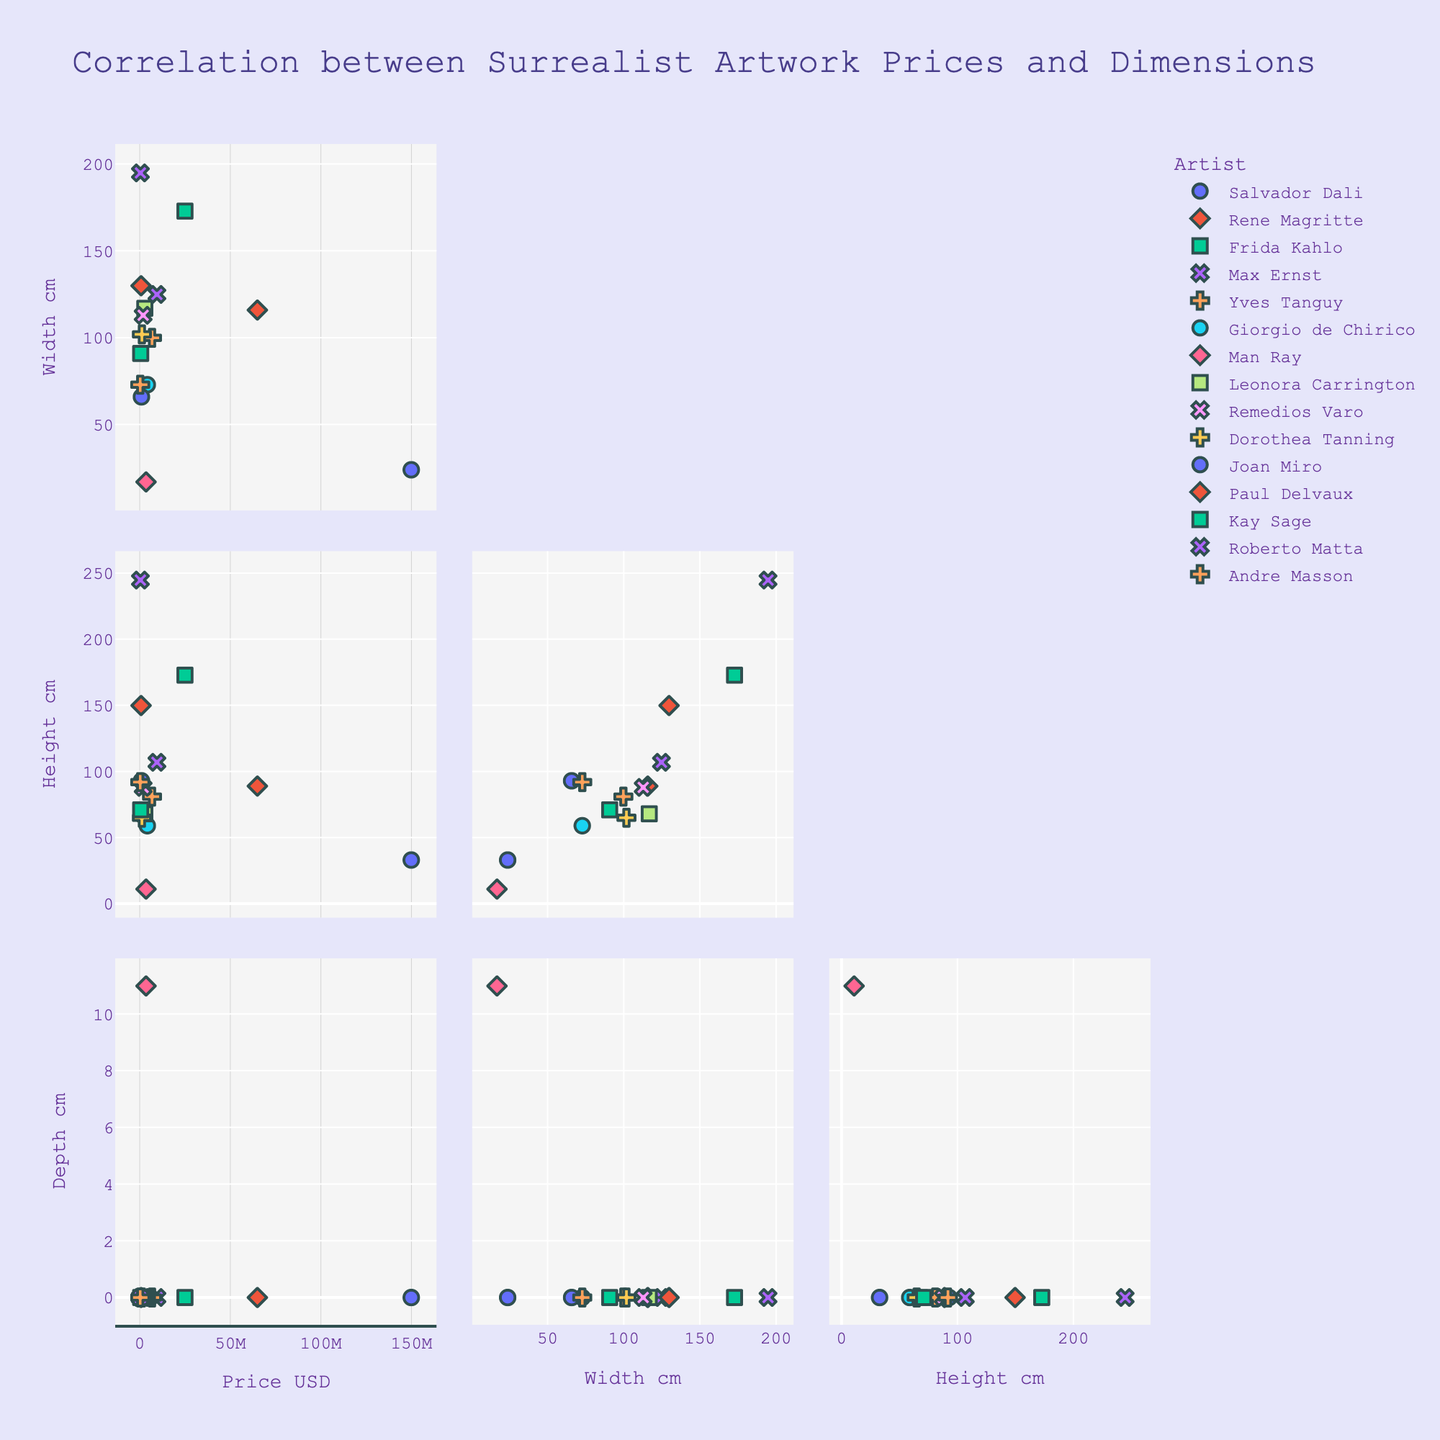What is the title of the plot? The title of the plot is displayed at the top and clearly states the purpose of the plot, which is showing the correlation between artwork prices and dimensions.
Answer: Correlation between Surrealist Artwork Prices and Dimensions How many surrealist artworks have a recorded depth dimension? Look at the 'Depth_cm' dimension axis; count the number of points that are not at zero.
Answer: 1 Which artist's artwork has the highest price? Look at the Price_USD axis and identify the highest data point; trace this point to the corresponding Artist's label.
Answer: Salvador Dali Is there a positive correlation between Price (USD) and Height (cm)? Observe the scatter plot for Price (USD) versus Height (cm) and check if higher prices generally match with higher heights.
Answer: No Which artwork has the greatest height? Find the maximum value on the Height_cm axis and trace it to the corresponding artwork label.
Answer: The Vertigo of Eros Do all artworks with zero depth have different prices? Observe the scatter plots where Depth_cm is zero and compare the prices.
Answer: Yes What dimensions appear to have the most linear relationship with the price? Evaluate the scatter plots of Price vs. Width, Price vs. Height, and Price vs. Depth for linearity (points aligning along a line).
Answer: Width Which artwork by Rene Magritte has the representing data points on the scatter plots? Locate symbols/color corresponding to Rene Magritte and identify the artwork labels attached to them.
Answer: The Son of Man Are larger artworks (considering both width and height) generally more expensive? Compare the scatter plots that involve Width and Height vs. Price.
Answer: No How does Man Ray’s artwork compare in terms of price and dimensions with the other artworks? Find Man Ray's data points on scatter plots, and compare Price, Width, Height, and Depth against other data points.
Answer: Lower price, smaller dimensions 